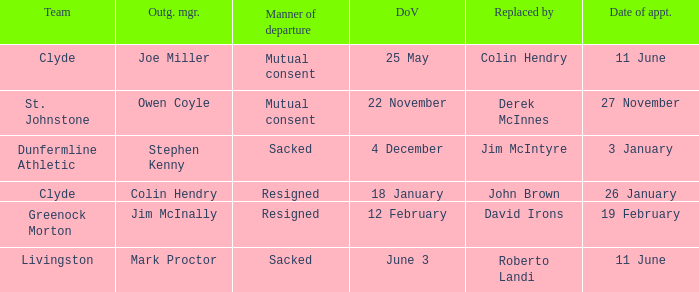Tell me the manner of departure for 3 january date of appointment Sacked. 